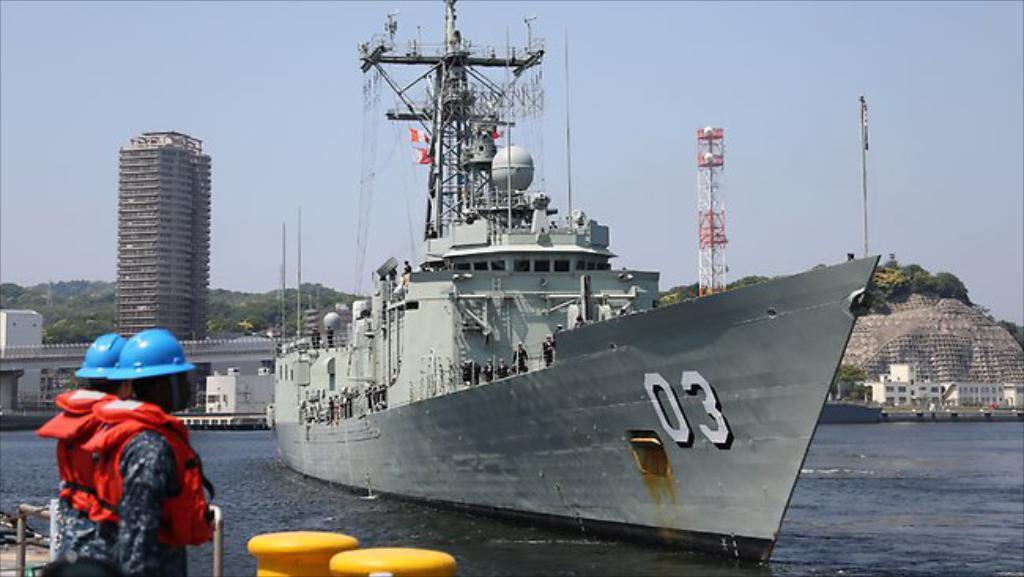Describe this image in one or two sentences. In this image we can see a ship. There are few houses and a building in the image. There are many trees in the image. There are two people standing in the image. There is a telephone tower and few hills in the image. 